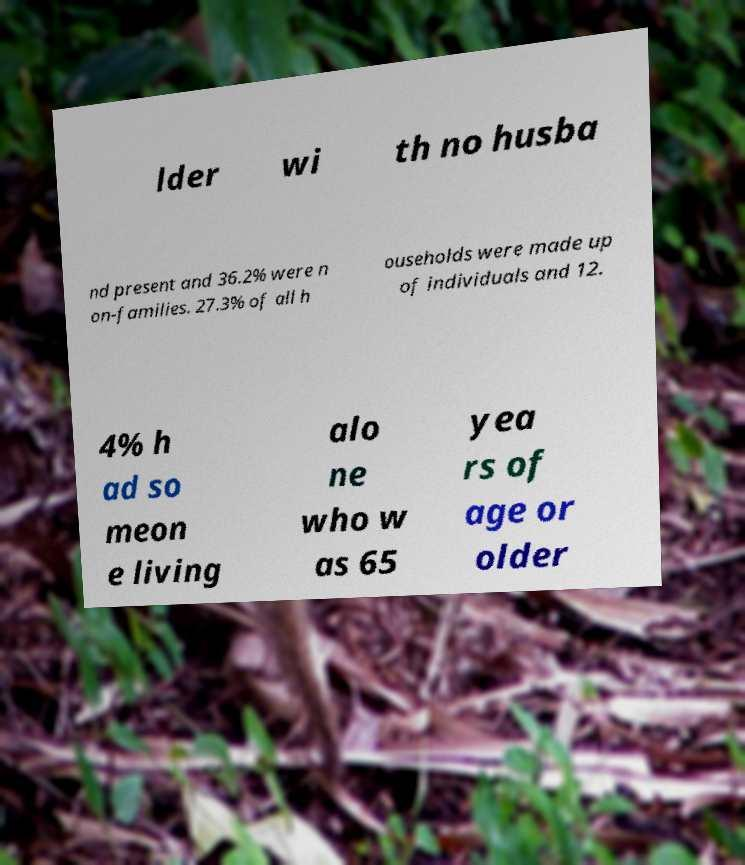Could you assist in decoding the text presented in this image and type it out clearly? lder wi th no husba nd present and 36.2% were n on-families. 27.3% of all h ouseholds were made up of individuals and 12. 4% h ad so meon e living alo ne who w as 65 yea rs of age or older 